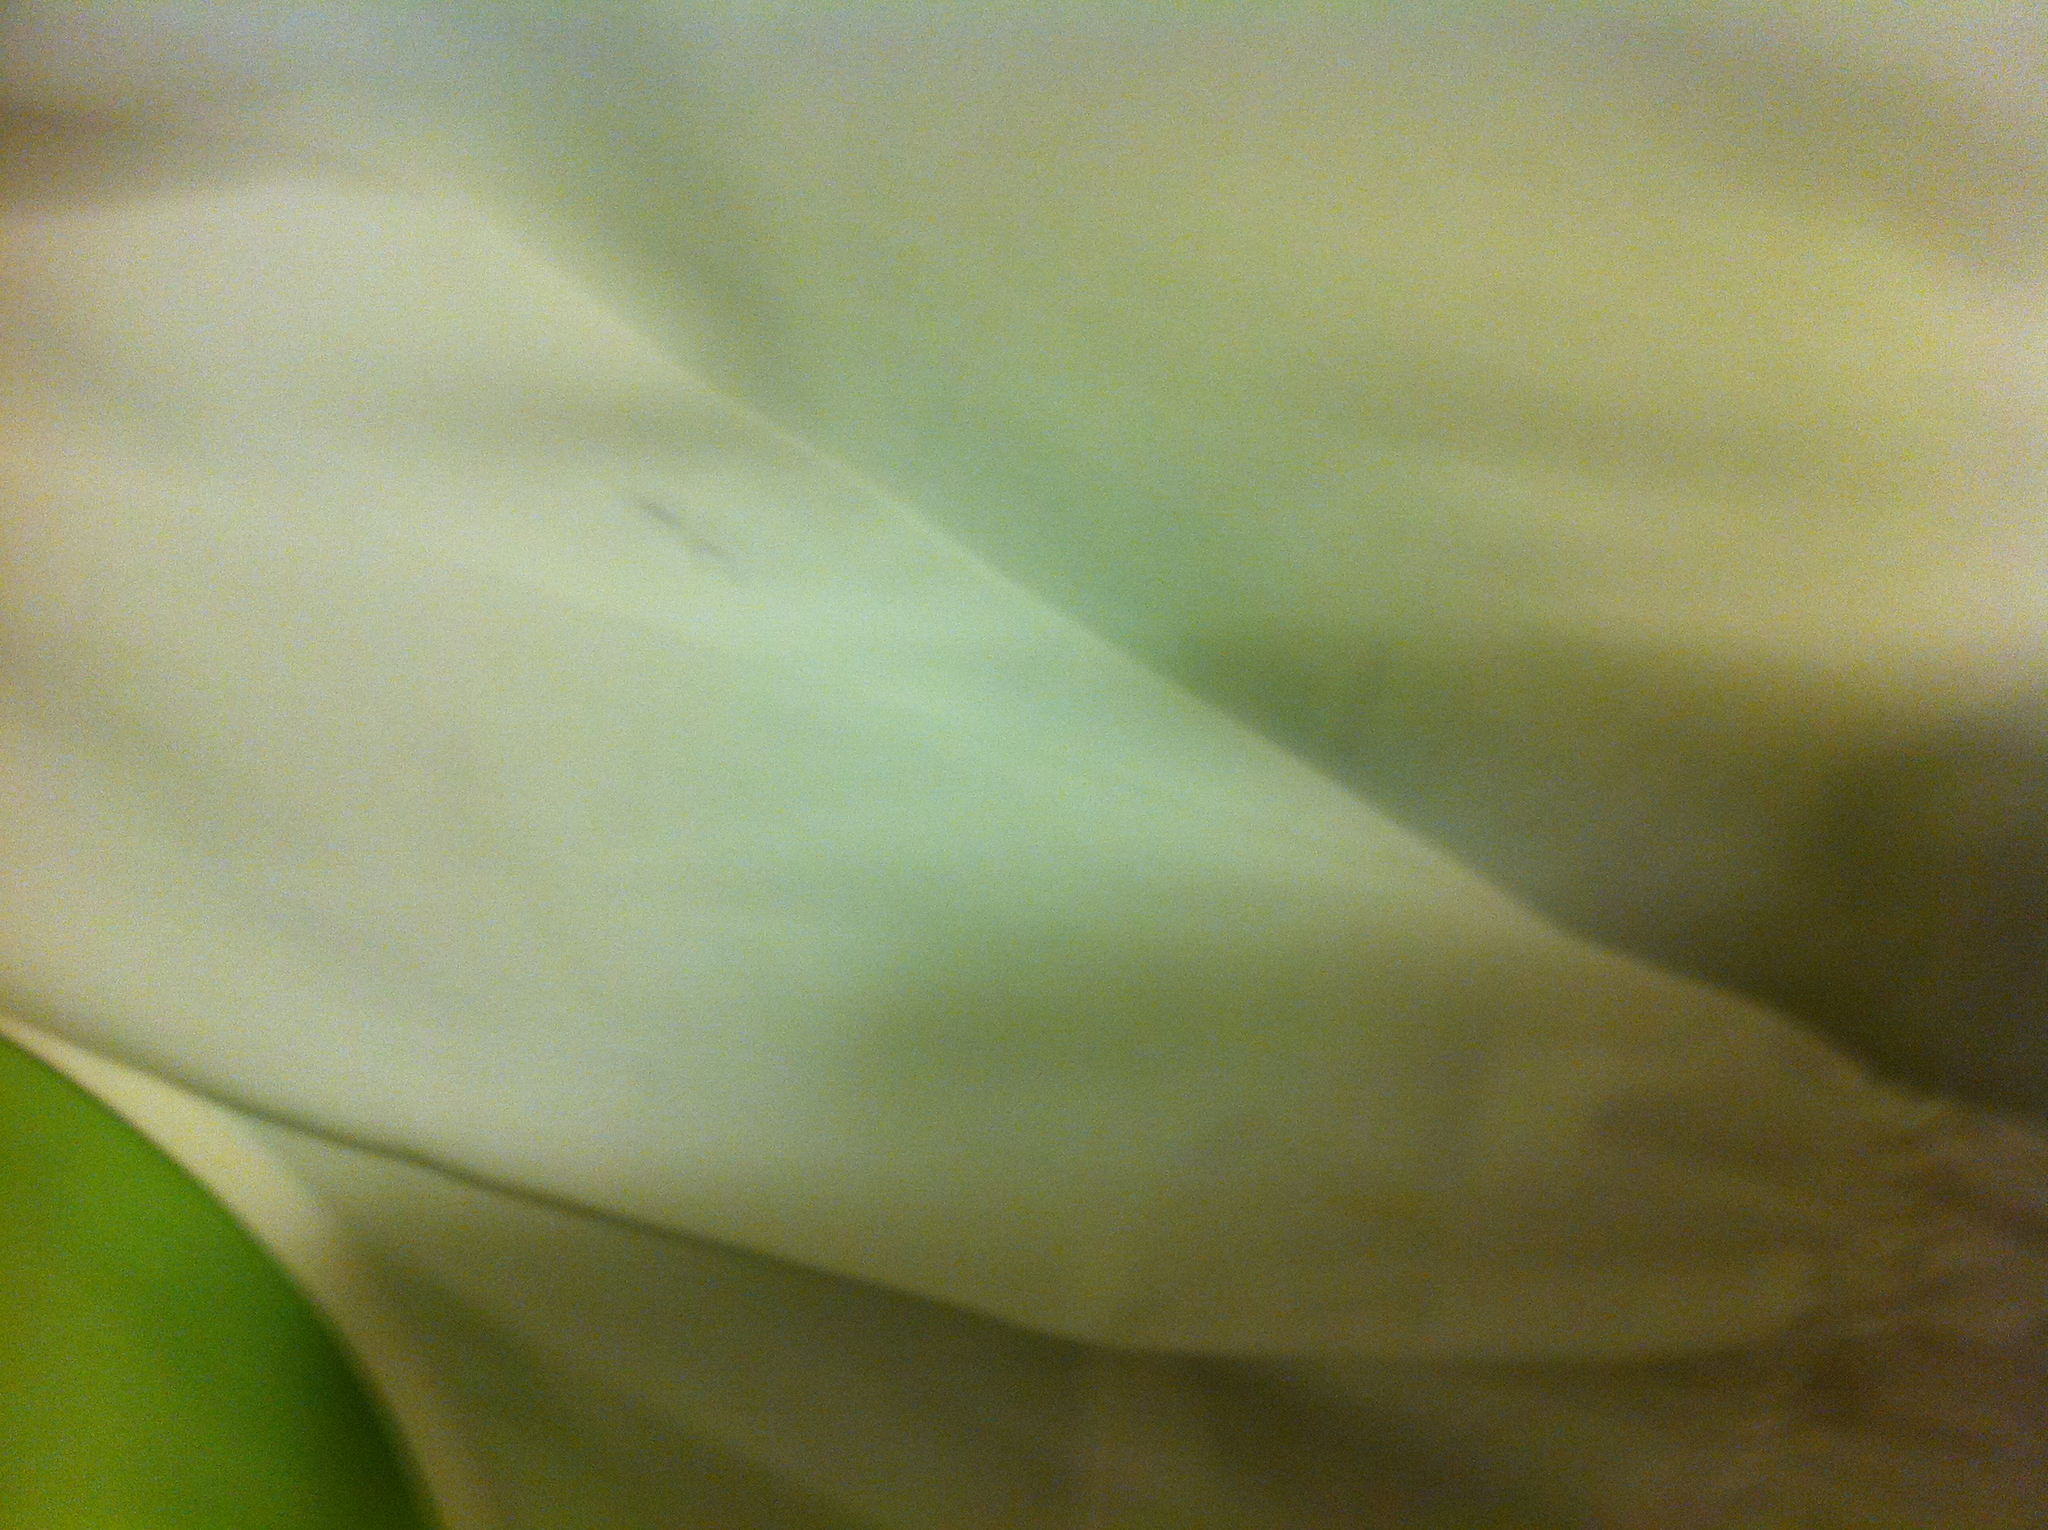What occasions would this shirt be appropriate for? Given its crisp white color and sleek appearance, this shirt would be versatile for a variety of occasions. It could be dressed down for a casual outing or paired with formal attire for events that require a smart dress code. 